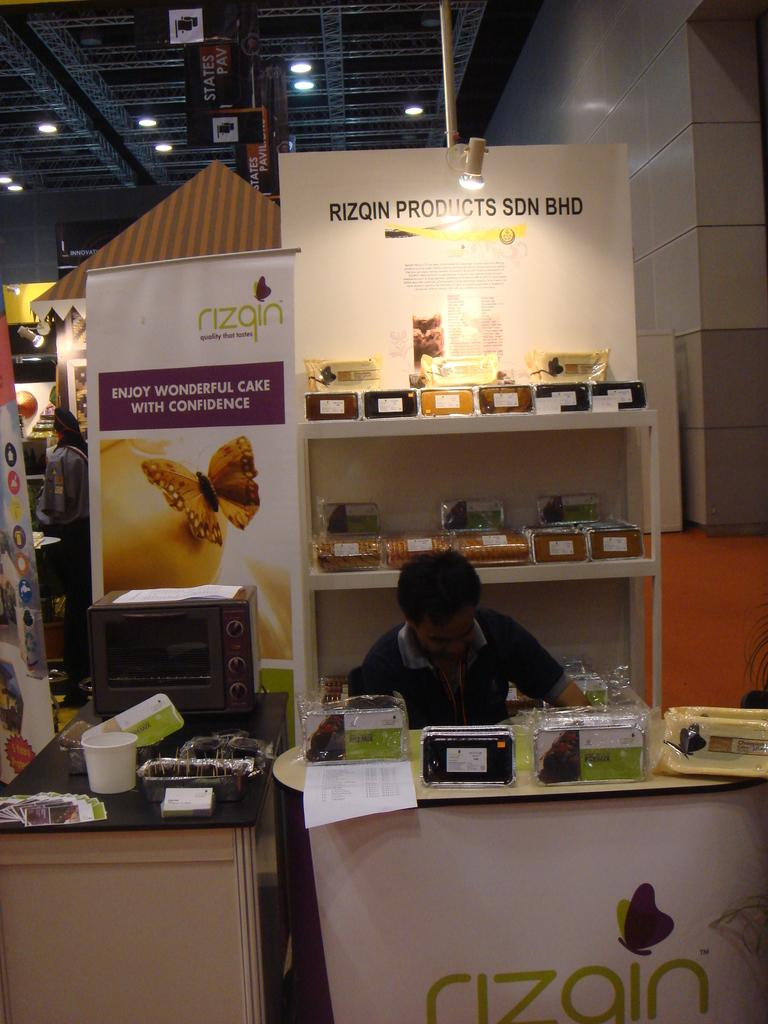<image>
Summarize the visual content of the image. A trade show booth for the brand Rizqin and its products. 